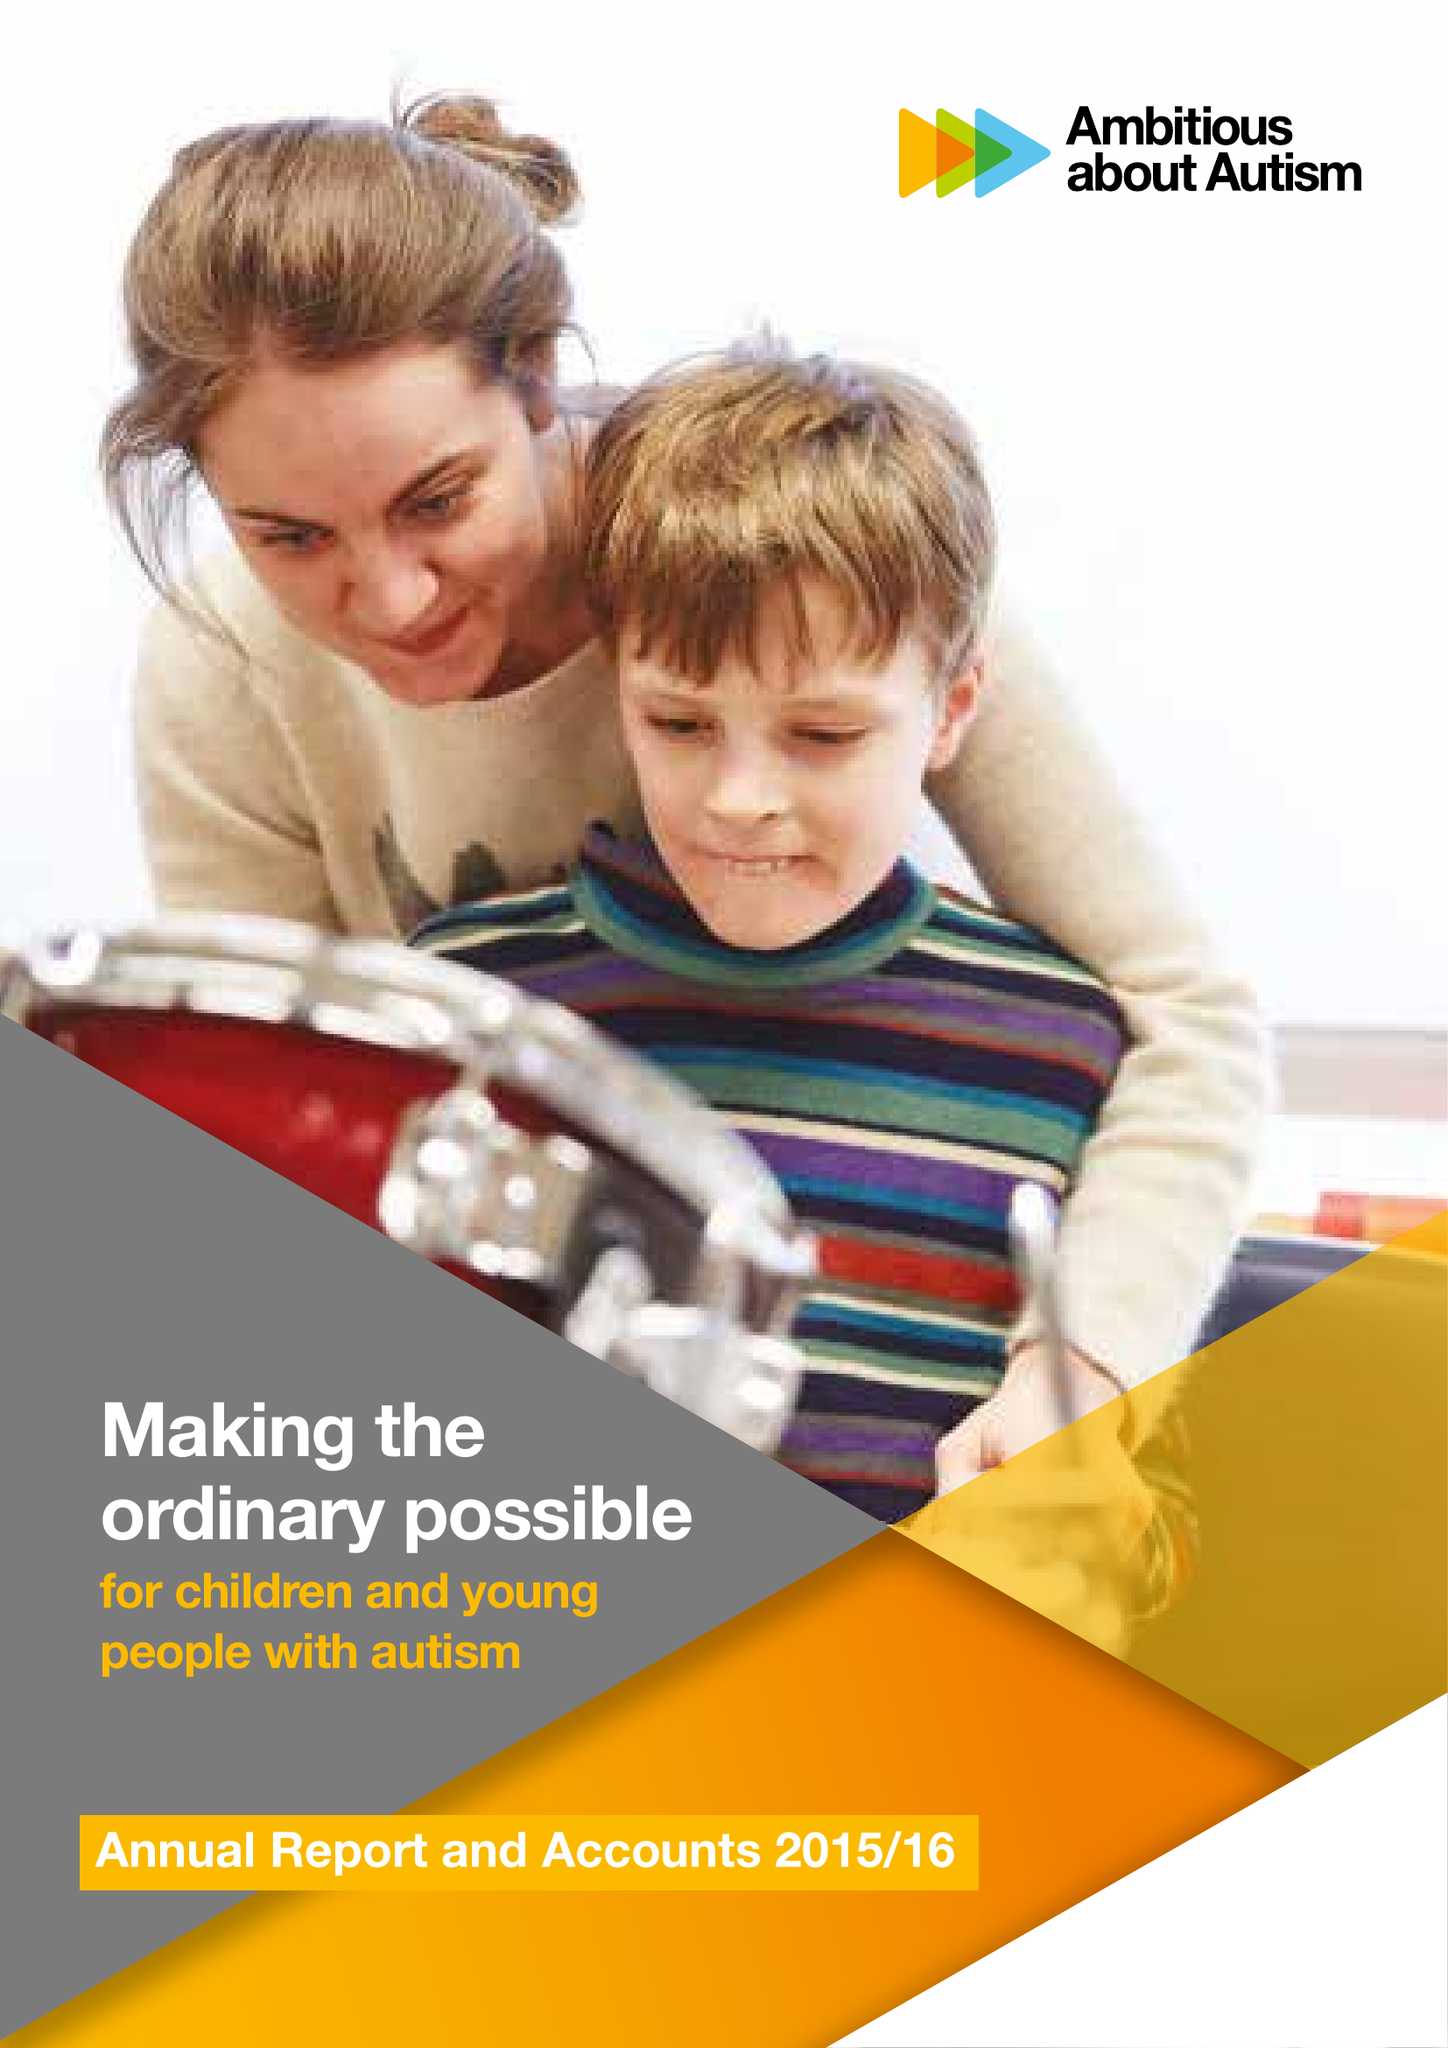What is the value for the income_annually_in_british_pounds?
Answer the question using a single word or phrase. 10789000.00 